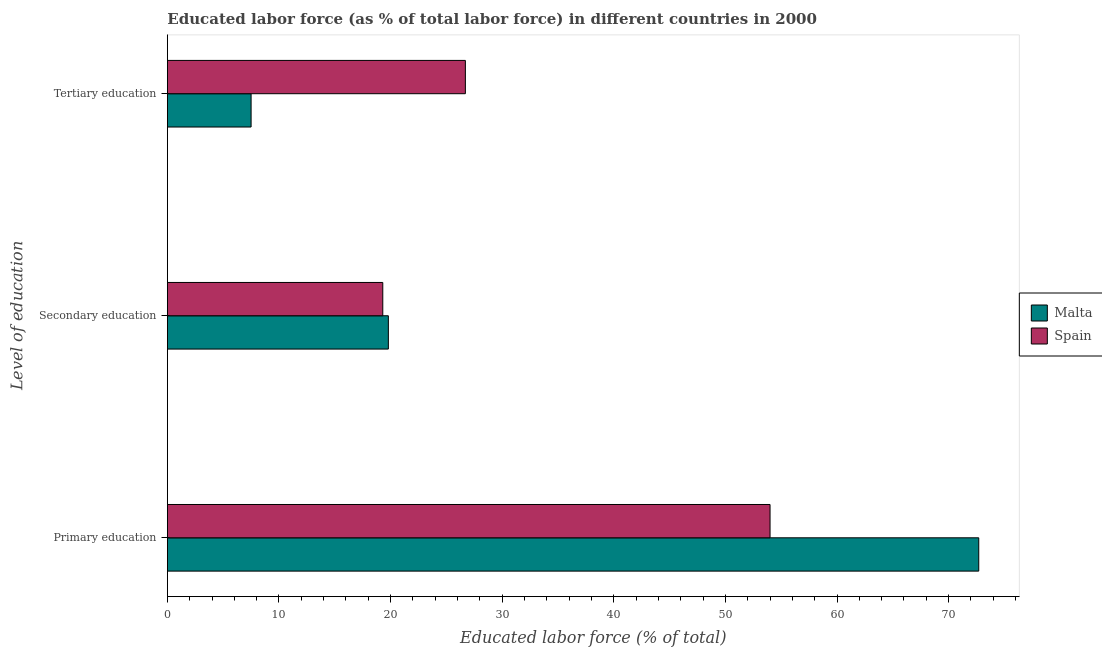How many groups of bars are there?
Offer a very short reply. 3. Are the number of bars on each tick of the Y-axis equal?
Keep it short and to the point. Yes. How many bars are there on the 3rd tick from the top?
Your answer should be compact. 2. How many bars are there on the 1st tick from the bottom?
Provide a succinct answer. 2. What is the label of the 1st group of bars from the top?
Provide a succinct answer. Tertiary education. What is the percentage of labor force who received primary education in Malta?
Offer a terse response. 72.7. Across all countries, what is the maximum percentage of labor force who received tertiary education?
Give a very brief answer. 26.7. Across all countries, what is the minimum percentage of labor force who received secondary education?
Make the answer very short. 19.3. In which country was the percentage of labor force who received primary education maximum?
Provide a short and direct response. Malta. What is the total percentage of labor force who received tertiary education in the graph?
Make the answer very short. 34.2. What is the difference between the percentage of labor force who received tertiary education in Malta and that in Spain?
Offer a very short reply. -19.2. What is the difference between the percentage of labor force who received tertiary education in Malta and the percentage of labor force who received primary education in Spain?
Your answer should be very brief. -46.5. What is the average percentage of labor force who received secondary education per country?
Your answer should be very brief. 19.55. What is the difference between the percentage of labor force who received secondary education and percentage of labor force who received tertiary education in Spain?
Your response must be concise. -7.4. What is the ratio of the percentage of labor force who received secondary education in Spain to that in Malta?
Offer a very short reply. 0.97. Is the percentage of labor force who received primary education in Spain less than that in Malta?
Give a very brief answer. Yes. What is the difference between the highest and the second highest percentage of labor force who received primary education?
Your answer should be very brief. 18.7. What is the difference between the highest and the lowest percentage of labor force who received primary education?
Keep it short and to the point. 18.7. In how many countries, is the percentage of labor force who received secondary education greater than the average percentage of labor force who received secondary education taken over all countries?
Offer a very short reply. 1. What does the 1st bar from the top in Secondary education represents?
Provide a short and direct response. Spain. What does the 1st bar from the bottom in Secondary education represents?
Provide a short and direct response. Malta. Is it the case that in every country, the sum of the percentage of labor force who received primary education and percentage of labor force who received secondary education is greater than the percentage of labor force who received tertiary education?
Your answer should be compact. Yes. Does the graph contain any zero values?
Give a very brief answer. No. Where does the legend appear in the graph?
Your answer should be compact. Center right. What is the title of the graph?
Provide a succinct answer. Educated labor force (as % of total labor force) in different countries in 2000. What is the label or title of the X-axis?
Provide a succinct answer. Educated labor force (% of total). What is the label or title of the Y-axis?
Offer a terse response. Level of education. What is the Educated labor force (% of total) in Malta in Primary education?
Offer a very short reply. 72.7. What is the Educated labor force (% of total) in Spain in Primary education?
Your answer should be compact. 54. What is the Educated labor force (% of total) of Malta in Secondary education?
Ensure brevity in your answer.  19.8. What is the Educated labor force (% of total) of Spain in Secondary education?
Your answer should be compact. 19.3. What is the Educated labor force (% of total) in Spain in Tertiary education?
Your answer should be compact. 26.7. Across all Level of education, what is the maximum Educated labor force (% of total) in Malta?
Keep it short and to the point. 72.7. Across all Level of education, what is the maximum Educated labor force (% of total) of Spain?
Your answer should be very brief. 54. Across all Level of education, what is the minimum Educated labor force (% of total) in Spain?
Your response must be concise. 19.3. What is the difference between the Educated labor force (% of total) in Malta in Primary education and that in Secondary education?
Provide a short and direct response. 52.9. What is the difference between the Educated labor force (% of total) in Spain in Primary education and that in Secondary education?
Your response must be concise. 34.7. What is the difference between the Educated labor force (% of total) of Malta in Primary education and that in Tertiary education?
Offer a terse response. 65.2. What is the difference between the Educated labor force (% of total) of Spain in Primary education and that in Tertiary education?
Give a very brief answer. 27.3. What is the difference between the Educated labor force (% of total) in Malta in Primary education and the Educated labor force (% of total) in Spain in Secondary education?
Provide a succinct answer. 53.4. What is the average Educated labor force (% of total) of Malta per Level of education?
Keep it short and to the point. 33.33. What is the average Educated labor force (% of total) of Spain per Level of education?
Provide a short and direct response. 33.33. What is the difference between the Educated labor force (% of total) of Malta and Educated labor force (% of total) of Spain in Primary education?
Your answer should be compact. 18.7. What is the difference between the Educated labor force (% of total) in Malta and Educated labor force (% of total) in Spain in Secondary education?
Provide a short and direct response. 0.5. What is the difference between the Educated labor force (% of total) in Malta and Educated labor force (% of total) in Spain in Tertiary education?
Offer a terse response. -19.2. What is the ratio of the Educated labor force (% of total) in Malta in Primary education to that in Secondary education?
Make the answer very short. 3.67. What is the ratio of the Educated labor force (% of total) in Spain in Primary education to that in Secondary education?
Provide a succinct answer. 2.8. What is the ratio of the Educated labor force (% of total) of Malta in Primary education to that in Tertiary education?
Offer a very short reply. 9.69. What is the ratio of the Educated labor force (% of total) in Spain in Primary education to that in Tertiary education?
Make the answer very short. 2.02. What is the ratio of the Educated labor force (% of total) of Malta in Secondary education to that in Tertiary education?
Ensure brevity in your answer.  2.64. What is the ratio of the Educated labor force (% of total) of Spain in Secondary education to that in Tertiary education?
Your answer should be compact. 0.72. What is the difference between the highest and the second highest Educated labor force (% of total) in Malta?
Keep it short and to the point. 52.9. What is the difference between the highest and the second highest Educated labor force (% of total) of Spain?
Offer a very short reply. 27.3. What is the difference between the highest and the lowest Educated labor force (% of total) in Malta?
Provide a short and direct response. 65.2. What is the difference between the highest and the lowest Educated labor force (% of total) of Spain?
Provide a succinct answer. 34.7. 